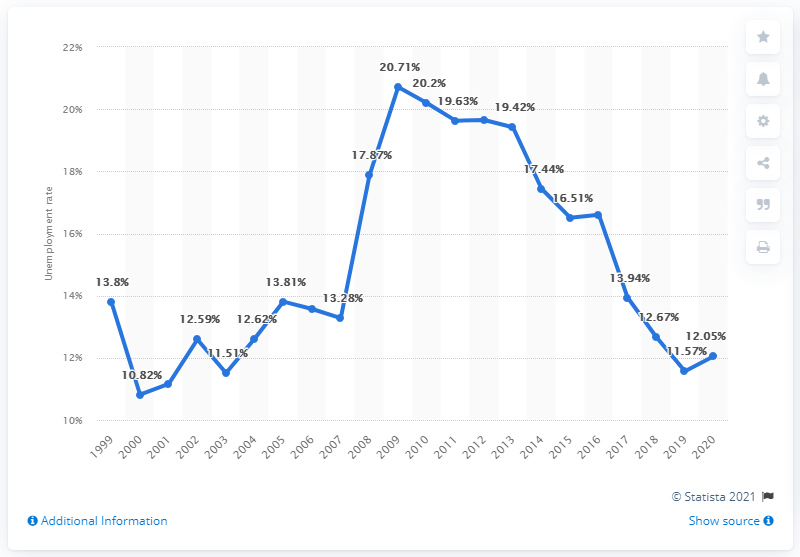Mention a couple of crucial points in this snapshot. The unemployment rate in Georgia in 2020 was 12.05%. 